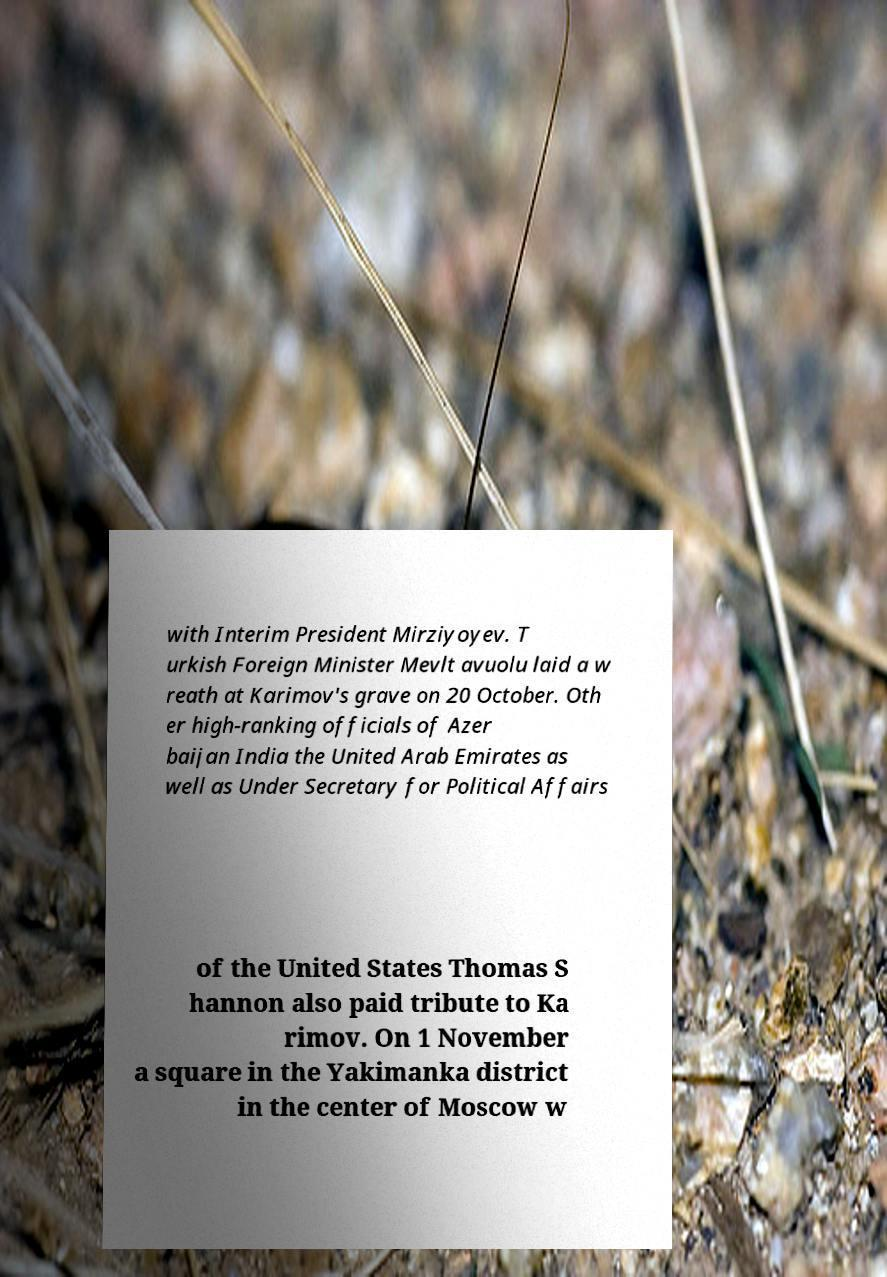Please read and relay the text visible in this image. What does it say? with Interim President Mirziyoyev. T urkish Foreign Minister Mevlt avuolu laid a w reath at Karimov's grave on 20 October. Oth er high-ranking officials of Azer baijan India the United Arab Emirates as well as Under Secretary for Political Affairs of the United States Thomas S hannon also paid tribute to Ka rimov. On 1 November a square in the Yakimanka district in the center of Moscow w 